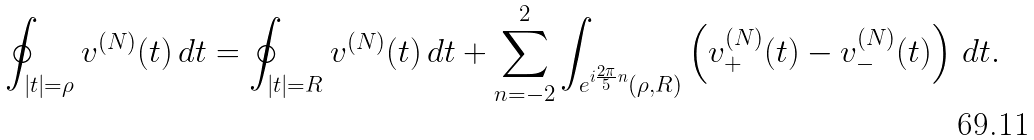Convert formula to latex. <formula><loc_0><loc_0><loc_500><loc_500>\oint _ { | t | = \rho } v ^ { ( N ) } ( t ) \, d t = \oint _ { | t | = R } v ^ { ( N ) } ( t ) \, d t + \sum _ { n = - 2 } ^ { 2 } \int _ { e ^ { i \frac { 2 \pi } { 5 } n } ( \rho , R ) } \left ( v _ { + } ^ { ( N ) } ( t ) - v _ { - } ^ { ( N ) } ( t ) \right ) \, d t .</formula> 